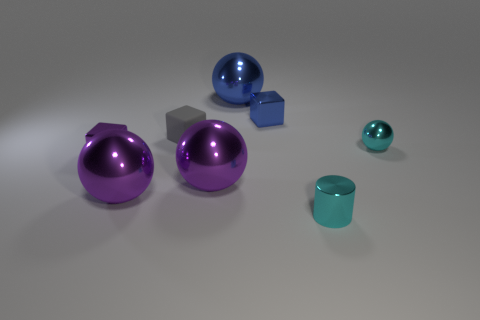How many shiny things are both on the right side of the tiny cyan metal cylinder and behind the cyan metal sphere?
Your response must be concise. 0. Are there an equal number of small cylinders that are behind the blue metal sphere and big balls that are to the left of the cyan ball?
Give a very brief answer. No. There is a tiny cyan thing that is behind the tiny shiny cylinder; does it have the same shape as the gray rubber object?
Keep it short and to the point. No. What shape is the blue object in front of the shiny sphere that is behind the small cyan object behind the cyan cylinder?
Your answer should be very brief. Cube. There is a object that is the same color as the small metallic cylinder; what shape is it?
Make the answer very short. Sphere. There is a large ball that is left of the big blue ball and to the right of the gray thing; what is its material?
Offer a terse response. Metal. Are there fewer small brown cylinders than small shiny cylinders?
Give a very brief answer. Yes. Does the small purple thing have the same shape as the tiny cyan thing behind the small cyan cylinder?
Your response must be concise. No. Is the size of the cyan object that is behind the cylinder the same as the purple cube?
Give a very brief answer. Yes. What shape is the purple thing that is the same size as the gray cube?
Provide a short and direct response. Cube. 